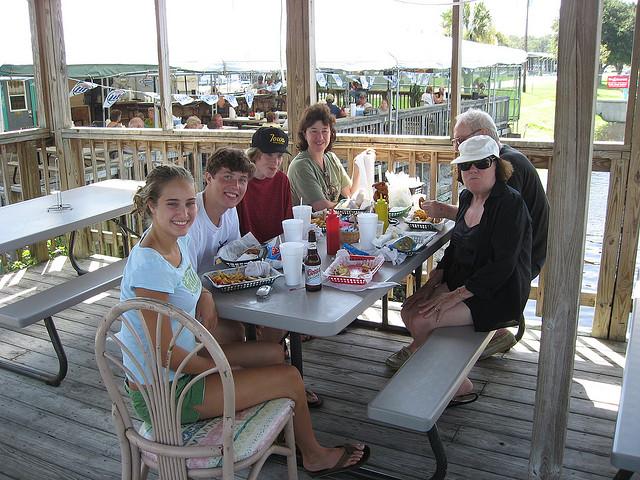How many people are eating?
Keep it brief. 6. What are they doing?
Concise answer only. Eating. Is this lakefront dining?
Answer briefly. Yes. How  many people are wearing glasses?
Keep it brief. 2. 